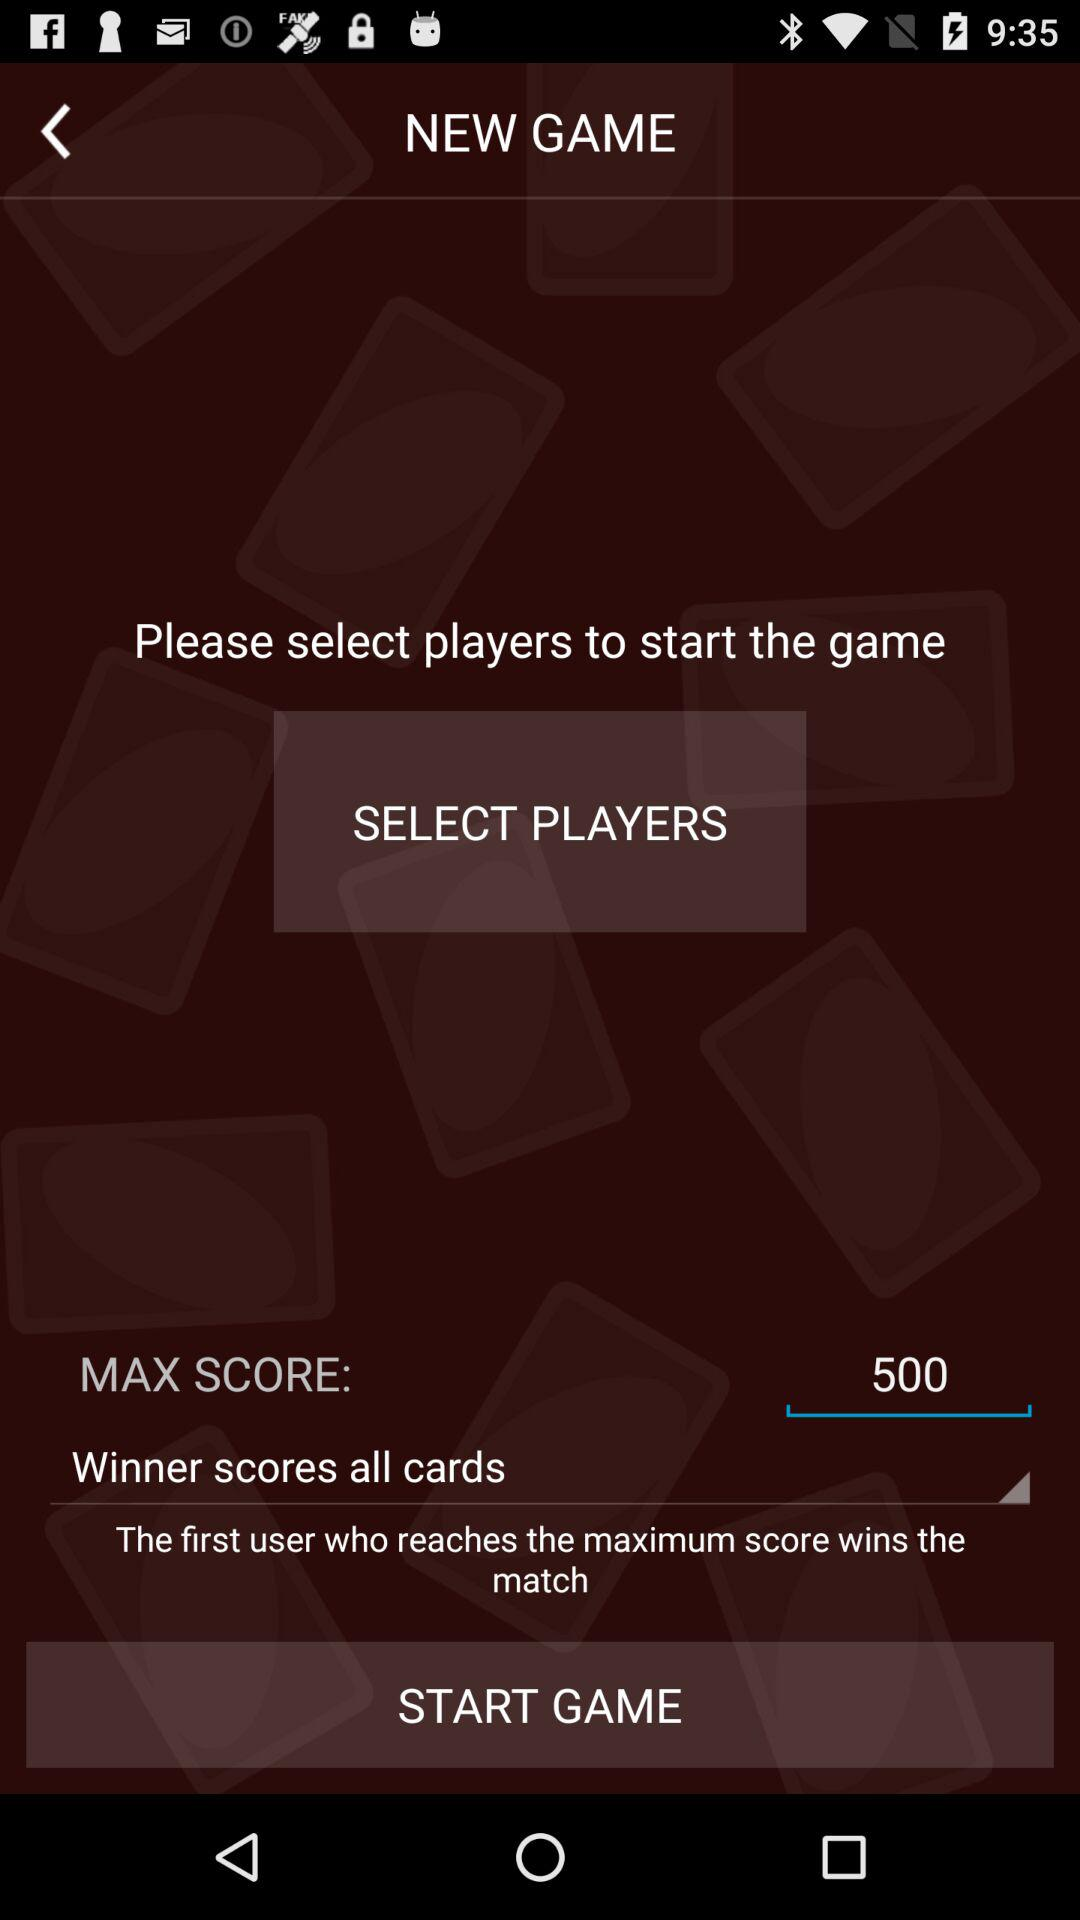What is the maximum score? The maximum score is 500. 